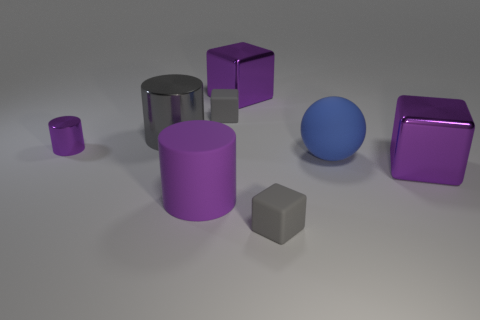What is the color of the big metal thing that is to the left of the matte block that is behind the gray matte thing in front of the big blue sphere?
Keep it short and to the point. Gray. Is the purple cube on the right side of the big matte sphere made of the same material as the purple cylinder behind the big sphere?
Make the answer very short. Yes. What number of things are big shiny objects that are in front of the blue thing or big matte blocks?
Provide a succinct answer. 1. What number of things are either small shiny cylinders or cylinders left of the gray cylinder?
Offer a very short reply. 1. What number of purple metal objects are the same size as the purple rubber object?
Offer a terse response. 2. Are there fewer large gray objects left of the small purple object than objects that are on the left side of the big gray cylinder?
Ensure brevity in your answer.  Yes. What number of metallic objects are either tiny yellow things or large objects?
Your answer should be very brief. 3. There is a small metal thing; what shape is it?
Your answer should be compact. Cylinder. What is the material of the gray object that is the same size as the matte cylinder?
Provide a succinct answer. Metal. How many large objects are either blue rubber objects or gray objects?
Provide a succinct answer. 2. 